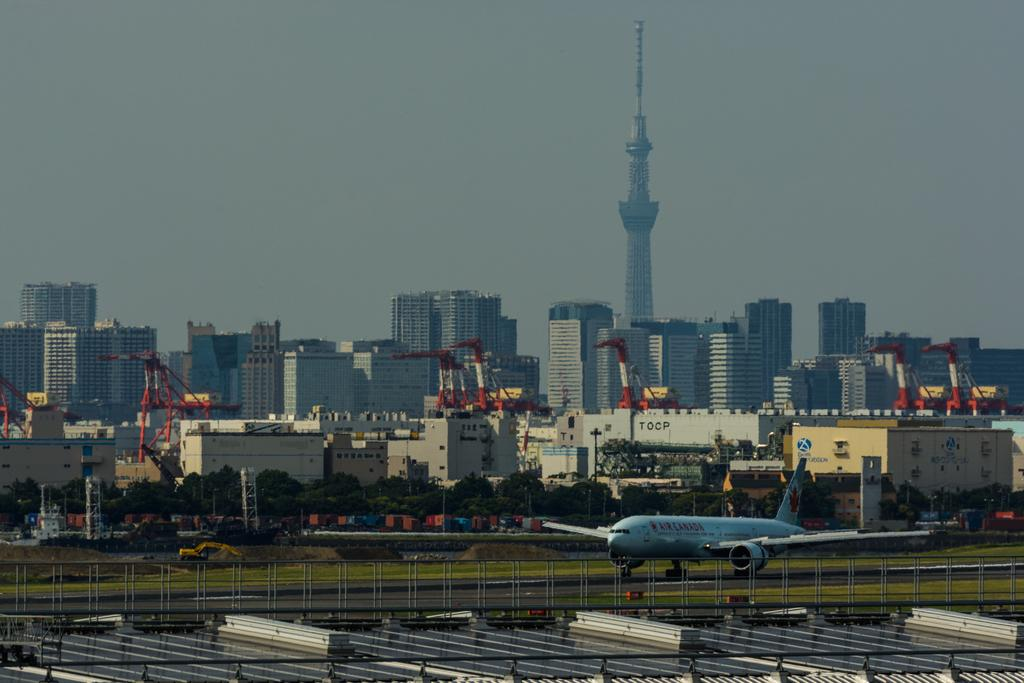What is the main subject of the image? The main subject of the image is an aeroplane. Can you describe the color of the aeroplane? The aeroplane is white. What else can be seen in the image besides the aeroplane? There are buildings and trees in the image. What is visible at the top of the image? The sky is visible at the top of the image. What type of dinner is being served on the aeroplane in the image? There is no dinner being served on the aeroplane in the image; it is not a scene from inside the aeroplane. How many feet tall is the aeroplane in the image? The image does not provide information about the height of the aeroplane, and it is not possible to determine its size based on the image alone. 